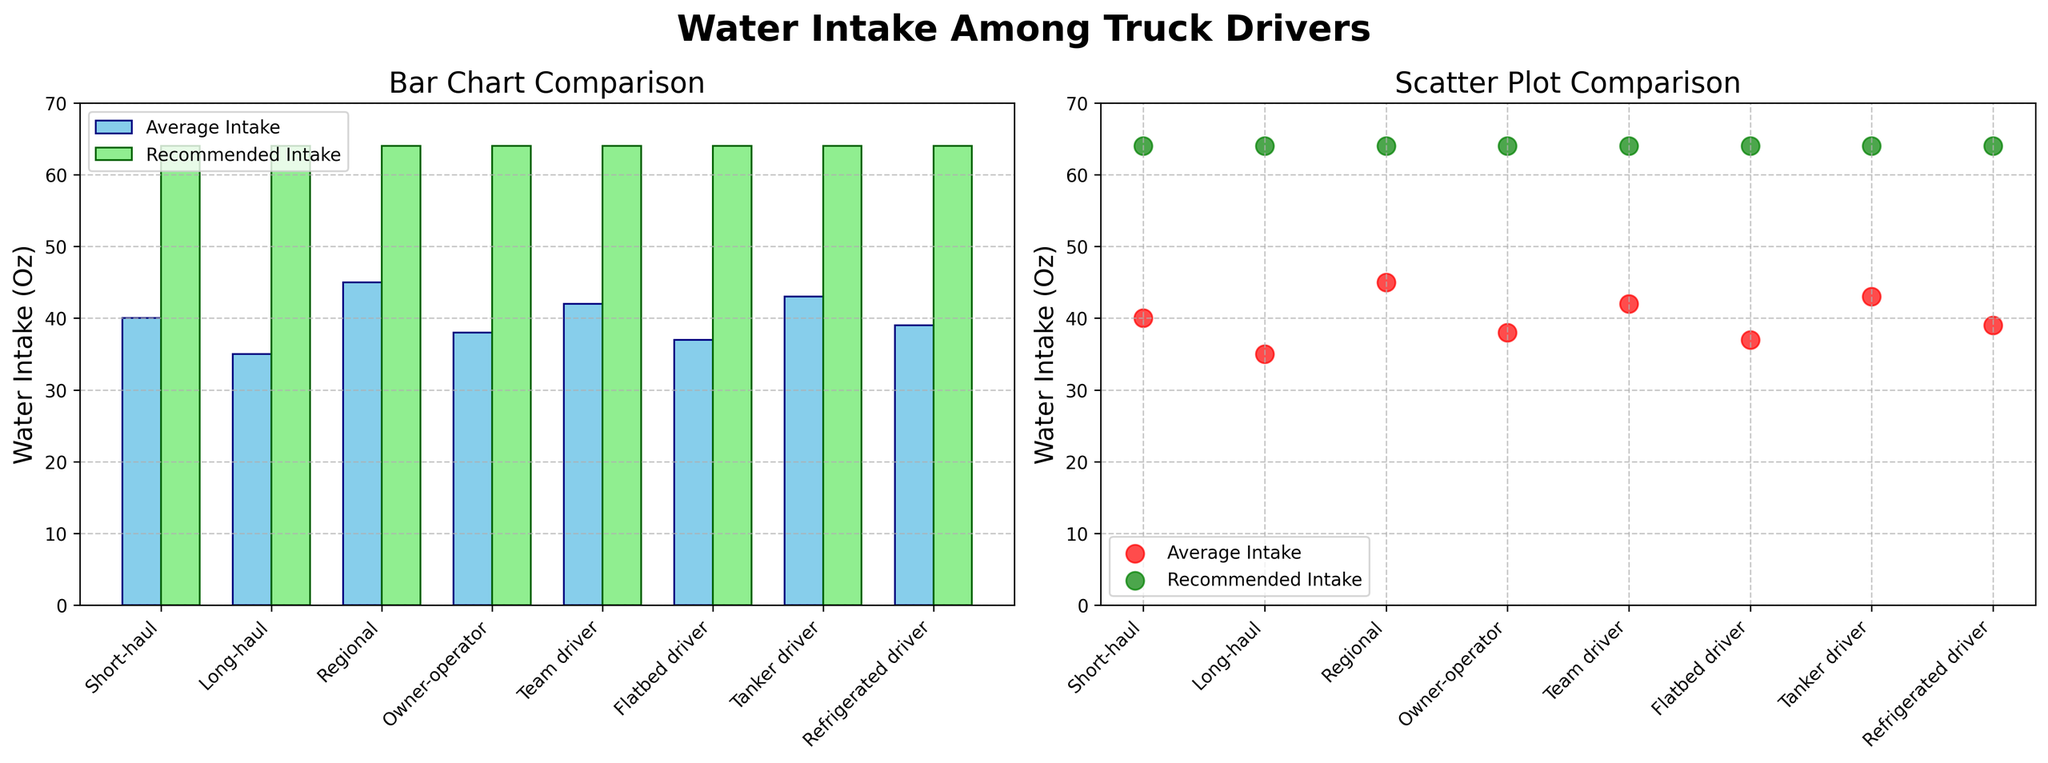What's the title of the figure? The title of the figure is displayed at the top center. It reads "Water Intake Among Truck Drivers".
Answer: Water Intake Among Truck Drivers How much water does a Long-haul driver intake on average per day and what is the recommended level? By referring to the bars and scatter points for Long-haul drivers in both subplots, we see the average intake is 35 ounces and the recommended level is 64 ounces.
Answer: Average: 35 oz, Recommended: 64 oz Which category of drivers has the highest average daily water intake? By examining the heights of the bars and scatter points in both subplots, Regional drivers have the highest average daily intake at 45 ounces.
Answer: Regional How much less water do Short-haul drivers drink on average than the recommended level? The difference between the recommended intake (64 ounces) and average intake for Short-haul drivers (40 ounces) is calculated as 64 - 40.
Answer: 24 oz Between Owner-operator and Team drivers, which group drinks more water on average and by how much? Owner-operator drivers drink 38 ounces on average, while Team drivers drink 42 ounces. The difference is 42 - 38 ounces.
Answer: Team drivers, 4 oz Which category has the closest average intake to the recommended level? By comparing the bars and scatter points in both subplots, the scatter points for Tanker drivers at 43 ounces is closest to the recommended intake of 64 ounces.
Answer: Tanker drivers What is the combined average water intake of Refrigerated and Flatbed drivers? Adding the average intake of Refrigerated drivers (39 ounces) and Flatbed drivers (37 ounces) gives 39 + 37.
Answer: 76 oz Based on the scatter plot, which two types of drivers have an average intake difference of exactly 5 ounces? By comparing the scatter points, Refrigerated drivers (39 ounces) and Owner-operator drivers (38 ounces) do not match, but Tanker drivers (43 ounces) and Short-haul drivers (40 ounces) difference is 43 - 40.
Answer: Refrigerated and Long-haul Looking at the bar chart, for which driver type is the discrepancy between average and recommended intake the largest? The driver types' discrepancy is visually compared, with Long-haul drivers having the largest, 64 (recommended) - 35 (average).
Answer: Long-haul In the scatter plot, which driver type appears closest to the title of the subplot? The tallest scatter point near the title belongs to Regional drivers.
Answer: Regional 